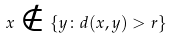Convert formula to latex. <formula><loc_0><loc_0><loc_500><loc_500>x \notin \{ y \colon d ( x , y ) > r \}</formula> 